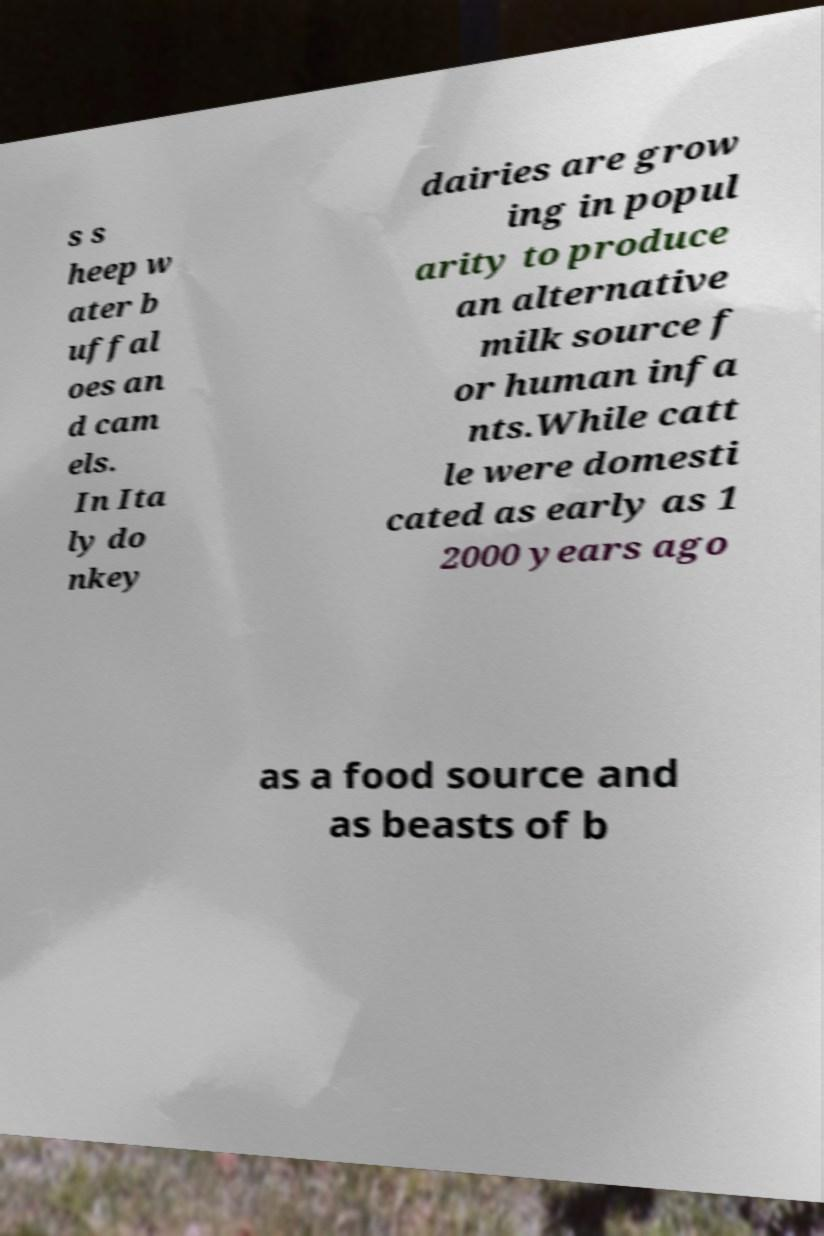Could you assist in decoding the text presented in this image and type it out clearly? s s heep w ater b uffal oes an d cam els. In Ita ly do nkey dairies are grow ing in popul arity to produce an alternative milk source f or human infa nts.While catt le were domesti cated as early as 1 2000 years ago as a food source and as beasts of b 